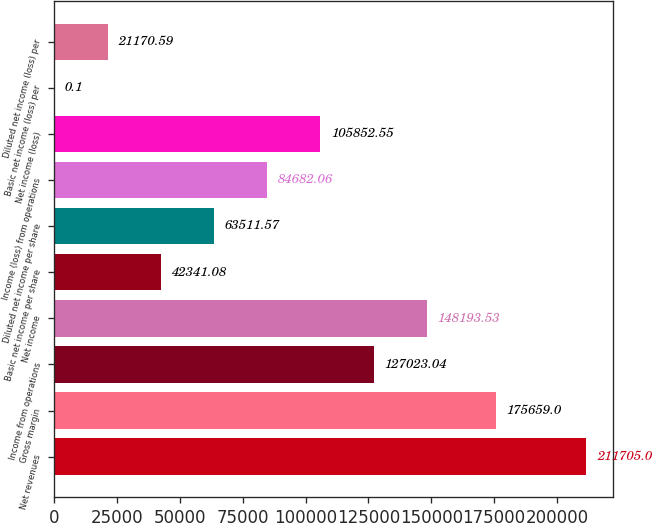Convert chart. <chart><loc_0><loc_0><loc_500><loc_500><bar_chart><fcel>Net revenues<fcel>Gross margin<fcel>Income from operations<fcel>Net income<fcel>Basic net income per share<fcel>Diluted net income per share<fcel>Income (loss) from operations<fcel>Net income (loss)<fcel>Basic net income (loss) per<fcel>Diluted net income (loss) per<nl><fcel>211705<fcel>175659<fcel>127023<fcel>148194<fcel>42341.1<fcel>63511.6<fcel>84682.1<fcel>105853<fcel>0.1<fcel>21170.6<nl></chart> 